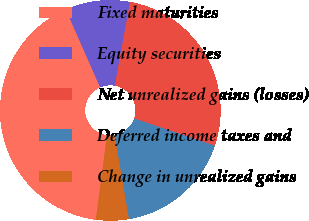Convert chart to OTSL. <chart><loc_0><loc_0><loc_500><loc_500><pie_chart><fcel>Fixed maturities<fcel>Equity securities<fcel>Net unrealized gains (losses)<fcel>Deferred income taxes and<fcel>Change in unrealized gains<nl><fcel>41.3%<fcel>9.48%<fcel>27.3%<fcel>17.13%<fcel>4.79%<nl></chart> 